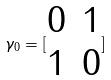Convert formula to latex. <formula><loc_0><loc_0><loc_500><loc_500>\gamma _ { 0 } = [ \begin{matrix} 0 & 1 \\ 1 & 0 \end{matrix} ]</formula> 